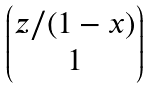<formula> <loc_0><loc_0><loc_500><loc_500>\begin{pmatrix} z / ( 1 - x ) \\ 1 \\ \end{pmatrix}</formula> 